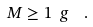<formula> <loc_0><loc_0><loc_500><loc_500>M \geq 1 \ g \ \ .</formula> 